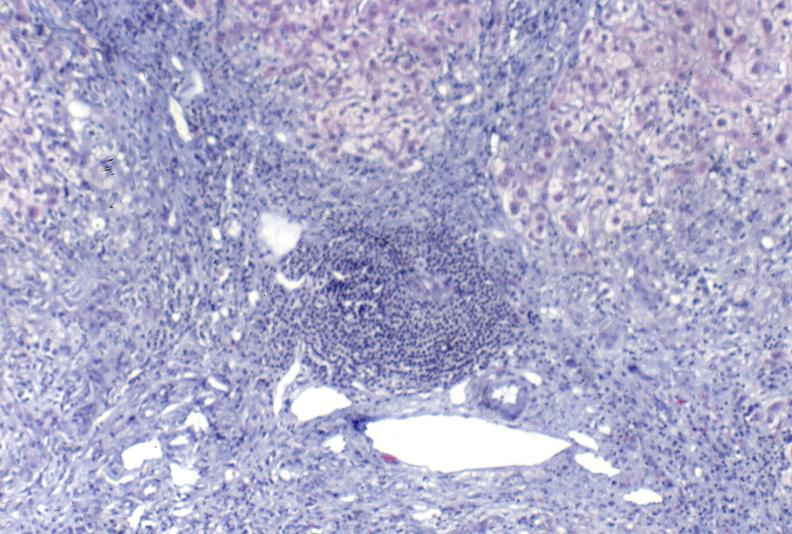s hepatobiliary present?
Answer the question using a single word or phrase. Yes 